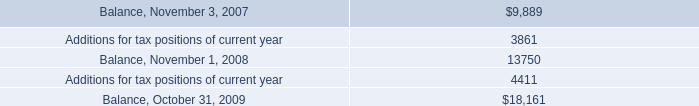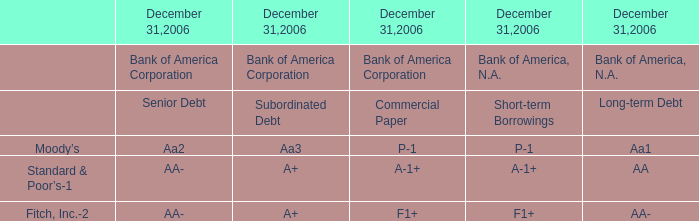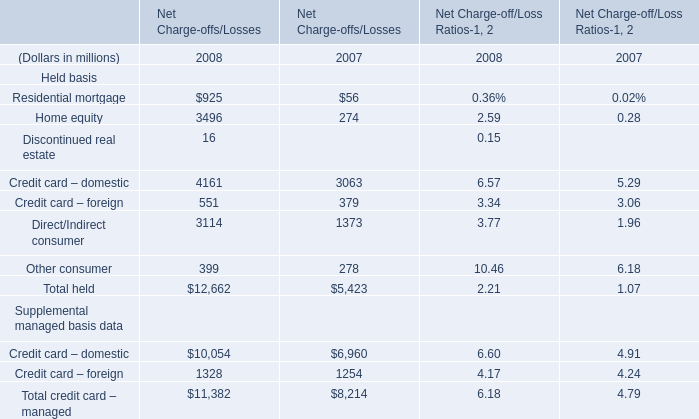What's the total amount of Residential mortgage and Home equity of Net Charge-offs/Losses in 2008? (in million) 
Computations: (925 + 3496)
Answer: 4421.0. 